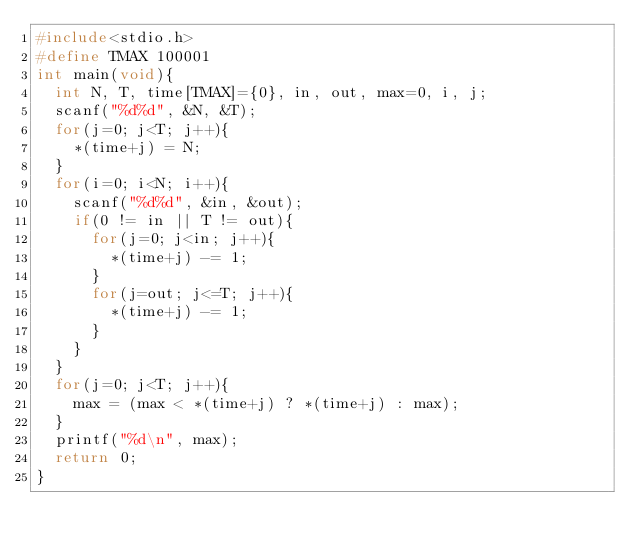Convert code to text. <code><loc_0><loc_0><loc_500><loc_500><_C_>#include<stdio.h>
#define TMAX 100001
int main(void){
	int N, T, time[TMAX]={0}, in, out, max=0, i, j;
	scanf("%d%d", &N, &T);
	for(j=0; j<T; j++){
		*(time+j) = N;
	}
	for(i=0; i<N; i++){
		scanf("%d%d", &in, &out);
		if(0 != in || T != out){
			for(j=0; j<in; j++){
				*(time+j) -= 1;
			}
			for(j=out; j<=T; j++){
				*(time+j) -= 1;
			}
		}
	}
	for(j=0; j<T; j++){
		max = (max < *(time+j) ? *(time+j) : max);
	}
	printf("%d\n", max);
	return 0;
}</code> 